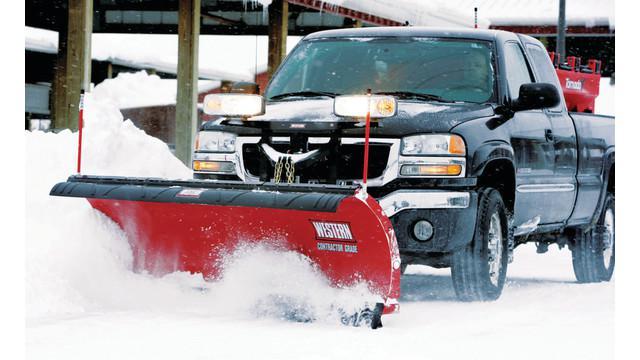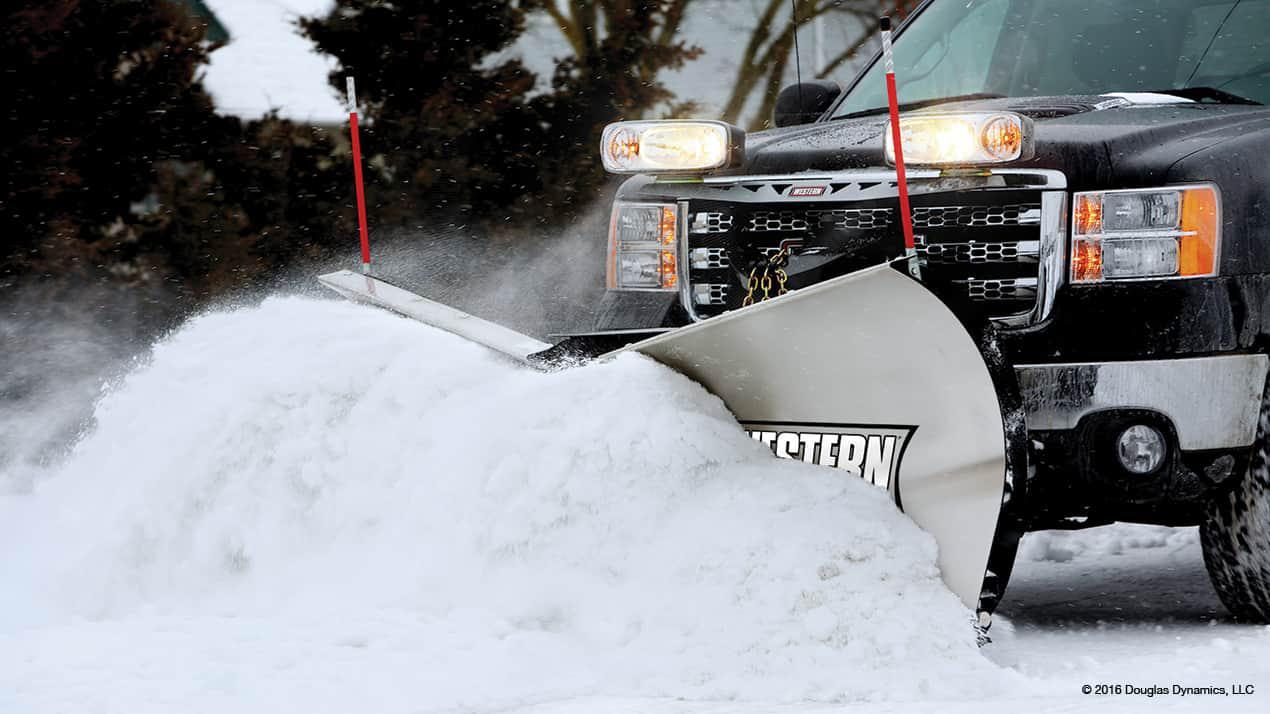The first image is the image on the left, the second image is the image on the right. Evaluate the accuracy of this statement regarding the images: "At least one truck is pushing snow.". Is it true? Answer yes or no. Yes. The first image is the image on the left, the second image is the image on the right. Assess this claim about the two images: "the trucks on are gray pavement in one of the images.". Correct or not? Answer yes or no. No. 